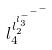Convert formula to latex. <formula><loc_0><loc_0><loc_500><loc_500>l _ { 4 } ^ { l _ { 2 } ^ { l _ { 3 } ^ { - ^ { - ^ { - } } } } }</formula> 